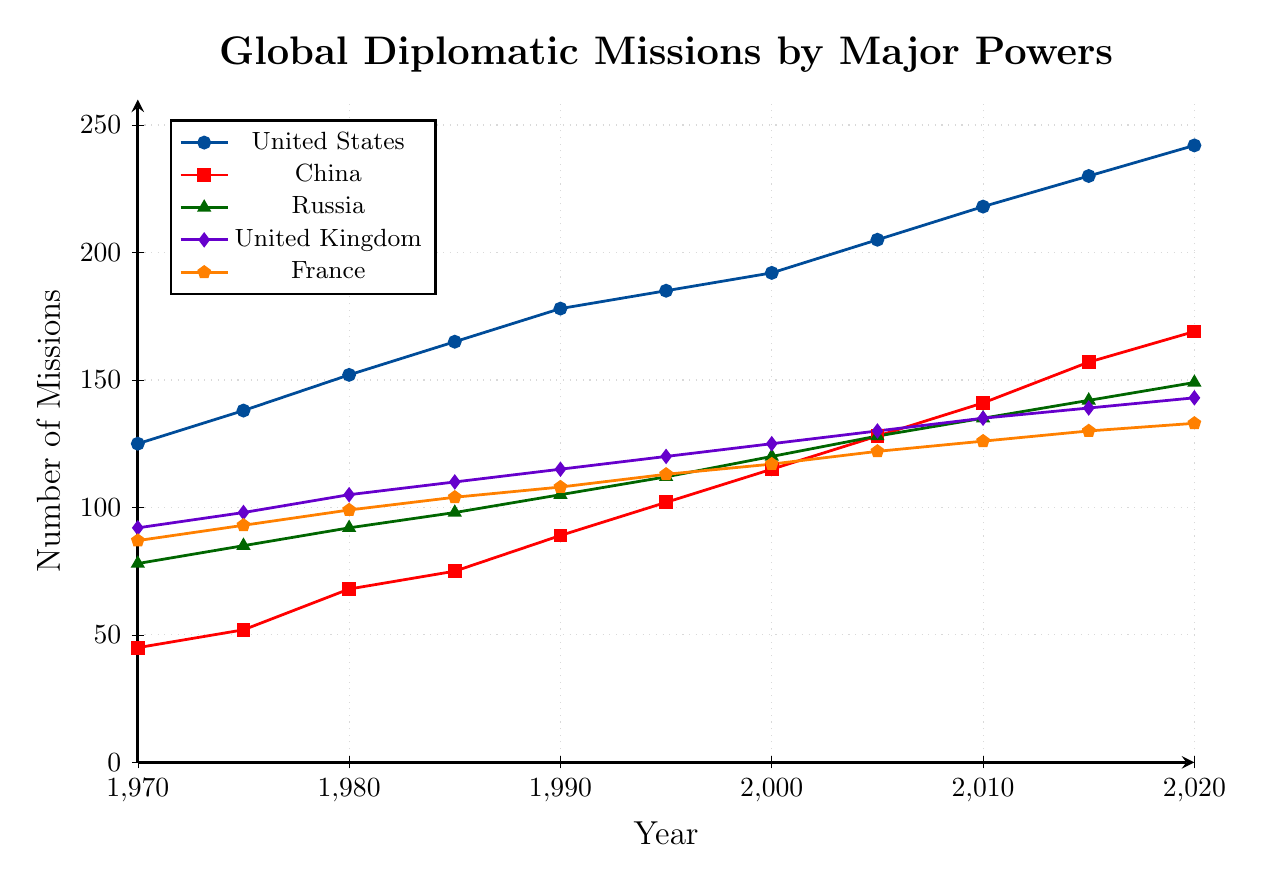What year did China overtake Russia in the number of diplomatic missions? From the chart, we can observe that the number of China's diplomatic missions crosses above Russia's between 1990 and 1995. By checking closer between those years, in 1995 China has 102 missions compared to Russia's 112, indicating that China had not overtaken Russia yet. In 2000, China has 115 missions while Russia has 120, which suggests that this overtaking happened between 1995 and 2000. Therefore, the year when China overtook Russia appears to be around 2000.
Answer: 2000 Which country had the highest number of diplomatic missions in 2010? By looking at the chart for the year 2010, we see that the country with the highest number of missions is the United States, which is marked with the highest point at that year. The number of missions for the United States in 2010 is 218.
Answer: United States What is the difference in the number of diplomatic missions between the United Kingdom and France in 1985? In 1985, the United Kingdom has 110 missions, while France has 104. To find the difference, we subtract the number of France's missions from the number of United Kingdom's missions: 110 - 104 = 6.
Answer: 6 Based on the chart, which two countries show the most similar trend from 2000 to 2020? Observing the lines for 2000 to 2020, the trend of the United Kingdom and France appears to be the most similar as both lines show similar slopes and patterns. Both lines are relatively close in their growth trajectory as well.
Answer: United Kingdom and France What is the total increase in the number of diplomatic missions for the United States from 1970 to 2020? The number of missions for the United States in 1970 is 125, and in 2020 is 242. To find the total increase, subtract the missions in 1970 from the missions in 2020: 242 - 125 = 117.
Answer: 117 How many more diplomatic missions did China have compared to France in 2020? In 2020, China had 169 diplomatic missions and France had 133. To find how many more missions China had compared to France, subtract France's missions from China's missions: 169 - 133 = 36.
Answer: 36 What is the average number of diplomatic missions of Russia in the years 1980, 1990, and 2000? To find the average, add up the missions of Russia in those years (92 in 1980, 105 in 1990, and 120 in 2000) and then divide by the number of years: (92 + 105 + 120) / 3 = 317 / 3 ≈ 106.
Answer: 106 In which year did the United States have its largest single-year increase in diplomatic missions? To determine this, we must examine the differences between each pair of consecutive years for the United States. The largest increase is between 2010 and 2015 where the number of missions increased from 218 to 230, a difference of 12. Therefore, the largest single-year increase is in 2010.
Answer: 2010 